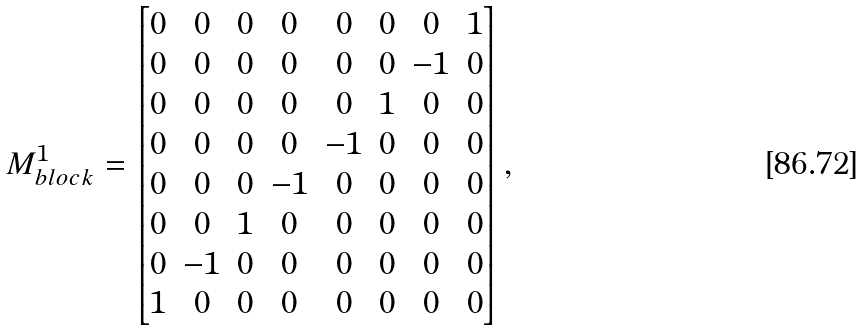Convert formula to latex. <formula><loc_0><loc_0><loc_500><loc_500>M _ { b l o c k } ^ { 1 } = \begin{bmatrix} 0 & 0 & 0 & 0 & 0 & 0 & 0 & 1 \\ 0 & 0 & 0 & 0 & 0 & 0 & - 1 & 0 \\ 0 & 0 & 0 & 0 & 0 & 1 & 0 & 0 \\ 0 & 0 & 0 & 0 & - 1 & 0 & 0 & 0 \\ 0 & 0 & 0 & - 1 & 0 & 0 & 0 & 0 \\ 0 & 0 & 1 & 0 & 0 & 0 & 0 & 0 \\ 0 & - 1 & 0 & 0 & 0 & 0 & 0 & 0 \\ 1 & 0 & 0 & 0 & 0 & 0 & 0 & 0 \end{bmatrix} ,</formula> 